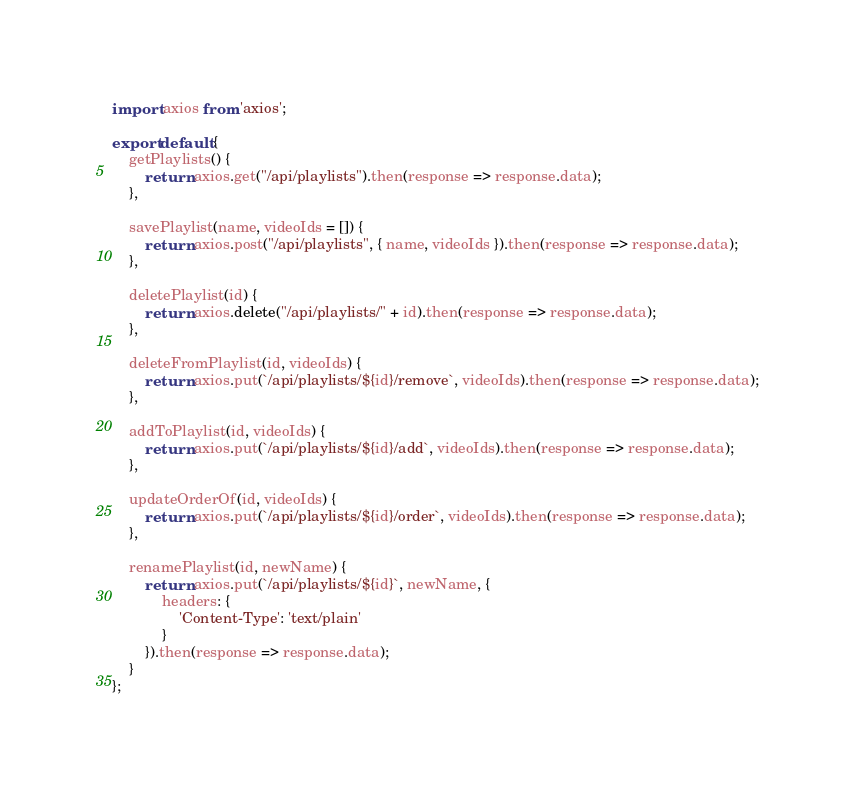Convert code to text. <code><loc_0><loc_0><loc_500><loc_500><_JavaScript_>import axios from 'axios';

export default {
    getPlaylists() {
        return axios.get("/api/playlists").then(response => response.data);
    },

    savePlaylist(name, videoIds = []) {
        return axios.post("/api/playlists", { name, videoIds }).then(response => response.data);
    },

    deletePlaylist(id) {
        return axios.delete("/api/playlists/" + id).then(response => response.data);
    },

    deleteFromPlaylist(id, videoIds) {
        return axios.put(`/api/playlists/${id}/remove`, videoIds).then(response => response.data);
    },

    addToPlaylist(id, videoIds) {
        return axios.put(`/api/playlists/${id}/add`, videoIds).then(response => response.data);
    },

    updateOrderOf(id, videoIds) {
        return axios.put(`/api/playlists/${id}/order`, videoIds).then(response => response.data);
    },

    renamePlaylist(id, newName) {
        return axios.put(`/api/playlists/${id}`, newName, {
            headers: {
                'Content-Type': 'text/plain'
            }
        }).then(response => response.data);
    }
};
</code> 